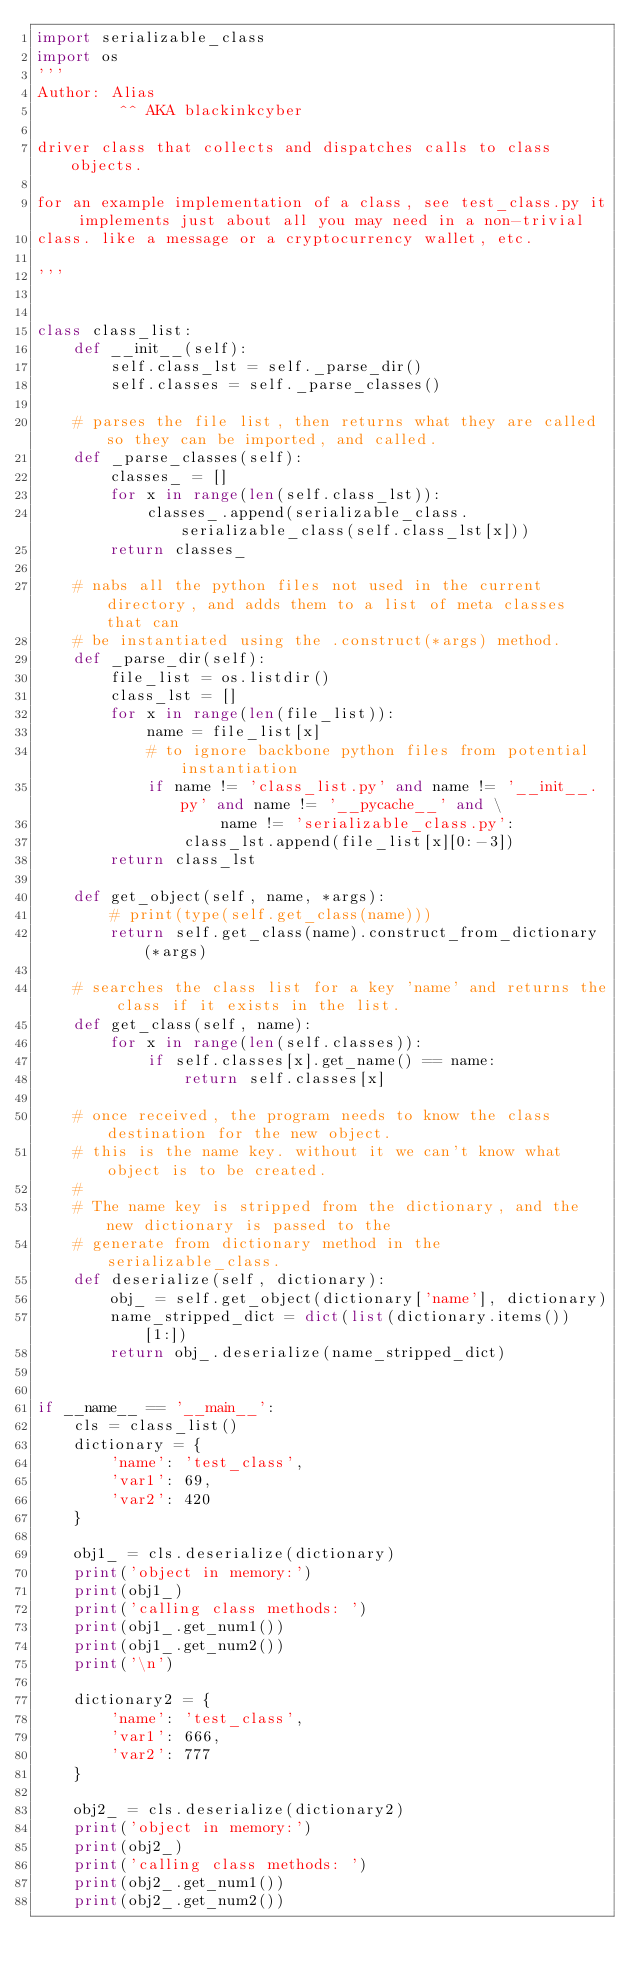Convert code to text. <code><loc_0><loc_0><loc_500><loc_500><_Python_>import serializable_class
import os
'''
Author: Alias
         ^^ AKA blackinkcyber

driver class that collects and dispatches calls to class objects.

for an example implementation of a class, see test_class.py it implements just about all you may need in a non-trivial
class. like a message or a cryptocurrency wallet, etc.

'''


class class_list:
    def __init__(self):
        self.class_lst = self._parse_dir()
        self.classes = self._parse_classes()

    # parses the file list, then returns what they are called so they can be imported, and called.
    def _parse_classes(self):
        classes_ = []
        for x in range(len(self.class_lst)):
            classes_.append(serializable_class.serializable_class(self.class_lst[x]))
        return classes_

    # nabs all the python files not used in the current directory, and adds them to a list of meta classes that can
    # be instantiated using the .construct(*args) method.
    def _parse_dir(self):
        file_list = os.listdir()
        class_lst = []
        for x in range(len(file_list)):
            name = file_list[x]
            # to ignore backbone python files from potential instantiation
            if name != 'class_list.py' and name != '__init__.py' and name != '__pycache__' and \
                    name != 'serializable_class.py':
                class_lst.append(file_list[x][0:-3])
        return class_lst

    def get_object(self, name, *args):
        # print(type(self.get_class(name)))
        return self.get_class(name).construct_from_dictionary(*args)

    # searches the class list for a key 'name' and returns the class if it exists in the list.
    def get_class(self, name):
        for x in range(len(self.classes)):
            if self.classes[x].get_name() == name:
                return self.classes[x]

    # once received, the program needs to know the class destination for the new object.
    # this is the name key. without it we can't know what object is to be created.
    #
    # The name key is stripped from the dictionary, and the new dictionary is passed to the
    # generate from dictionary method in the serializable_class.
    def deserialize(self, dictionary):
        obj_ = self.get_object(dictionary['name'], dictionary)
        name_stripped_dict = dict(list(dictionary.items())[1:])
        return obj_.deserialize(name_stripped_dict)


if __name__ == '__main__':
    cls = class_list()
    dictionary = {
        'name': 'test_class',
        'var1': 69,
        'var2': 420
    }

    obj1_ = cls.deserialize(dictionary)
    print('object in memory:')
    print(obj1_)
    print('calling class methods: ')
    print(obj1_.get_num1())
    print(obj1_.get_num2())
    print('\n')

    dictionary2 = {
        'name': 'test_class',
        'var1': 666,
        'var2': 777
    }

    obj2_ = cls.deserialize(dictionary2)
    print('object in memory:')
    print(obj2_)
    print('calling class methods: ')
    print(obj2_.get_num1())
    print(obj2_.get_num2())
</code> 